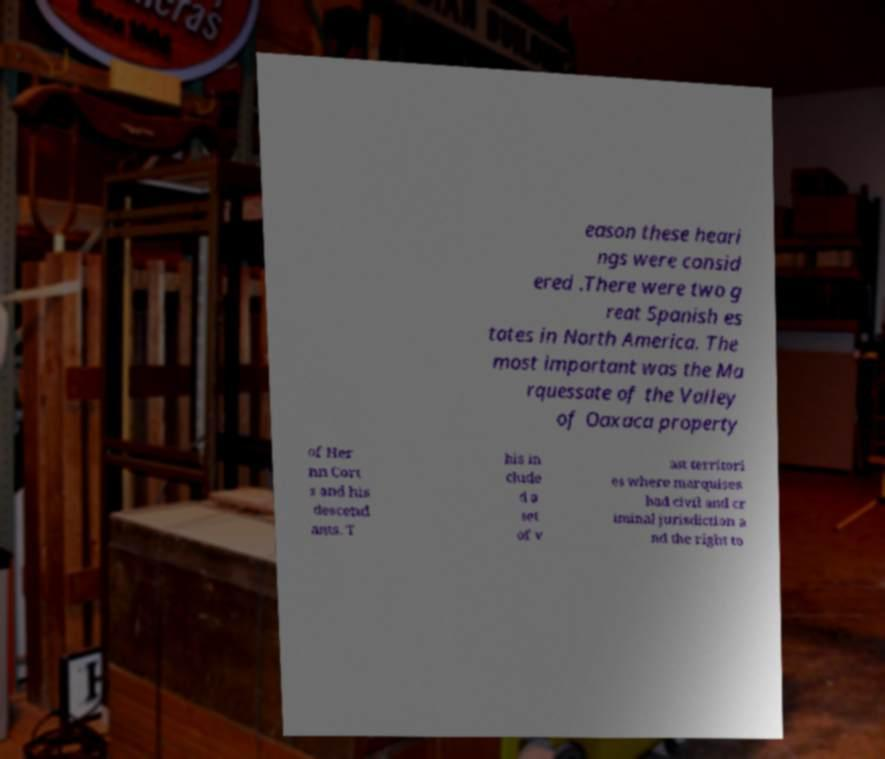Please identify and transcribe the text found in this image. eason these heari ngs were consid ered .There were two g reat Spanish es tates in North America. The most important was the Ma rquessate of the Valley of Oaxaca property of Her nn Cort s and his descend ants. T his in clude d a set of v ast territori es where marquises had civil and cr iminal jurisdiction a nd the right to 